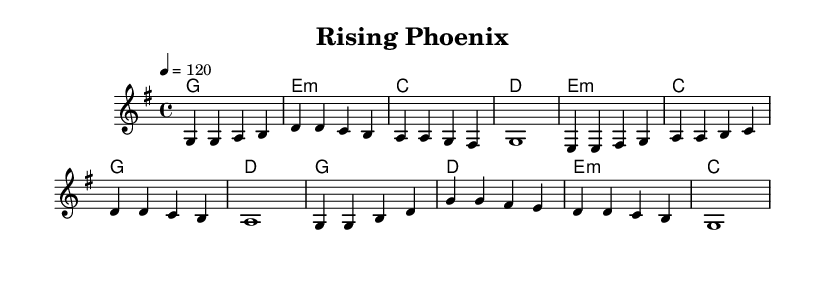What is the key signature of this music? The key signature is G major, indicated by one sharp (F#) in the key signature.
Answer: G major What is the time signature of this music? The time signature is found at the beginning of the score, showing that there are four beats per measure.
Answer: 4/4 What is the tempo marking of this music? The tempo marking at the beginning indicates that the music should be played at a speed of 120 beats per minute.
Answer: 120 How many measures are in the chorus section? By counting the measures in the chorus part from the score, there are a total of four measures.
Answer: 4 Which chord is played in the second measure of the verse? The second measure of the verse shows a chord of E minor, which consists of the notes E, G, and B.
Answer: E minor What is the note that starts the pre-chorus? The pre-chorus begins with the note E, as seen in the first measure of that section.
Answer: E What musical form does this song follow? Looking at the structure of the song, it follows a verse-pre-chorus-chorus pattern, a common structure in pop music.
Answer: Verse-pre-chorus-chorus 